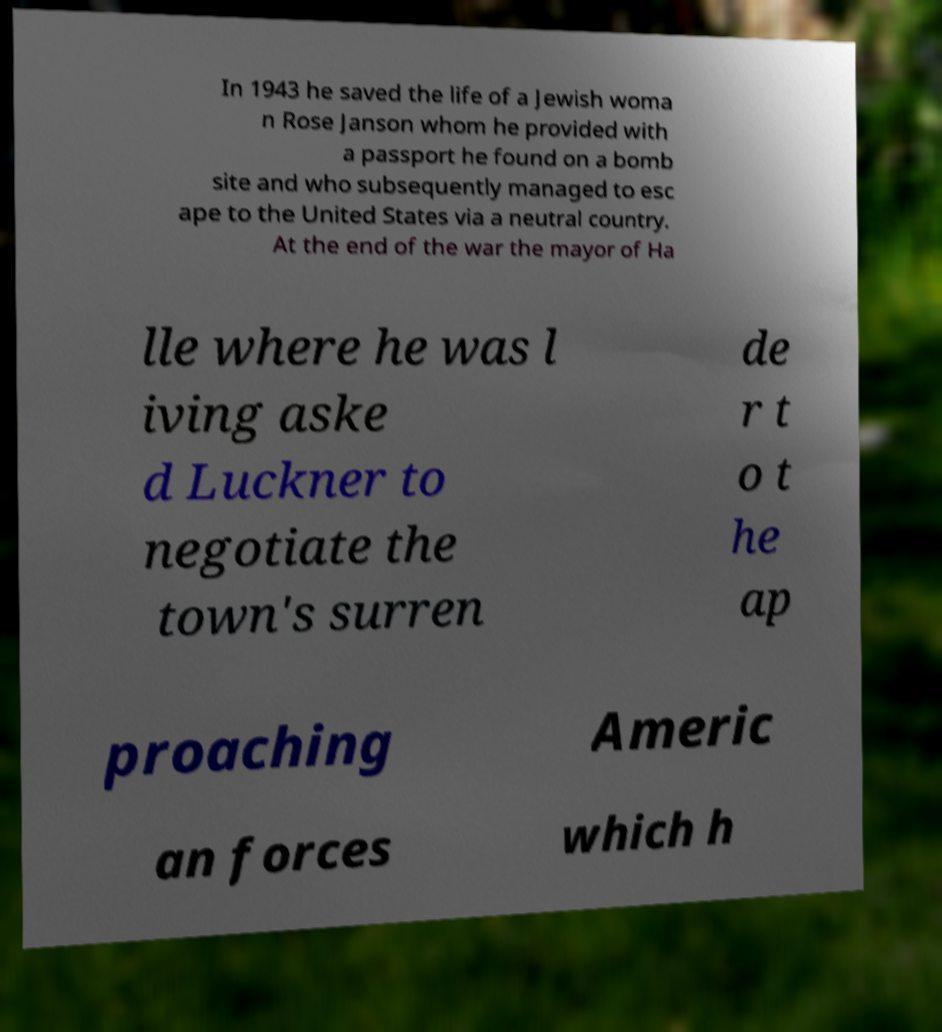For documentation purposes, I need the text within this image transcribed. Could you provide that? In 1943 he saved the life of a Jewish woma n Rose Janson whom he provided with a passport he found on a bomb site and who subsequently managed to esc ape to the United States via a neutral country. At the end of the war the mayor of Ha lle where he was l iving aske d Luckner to negotiate the town's surren de r t o t he ap proaching Americ an forces which h 